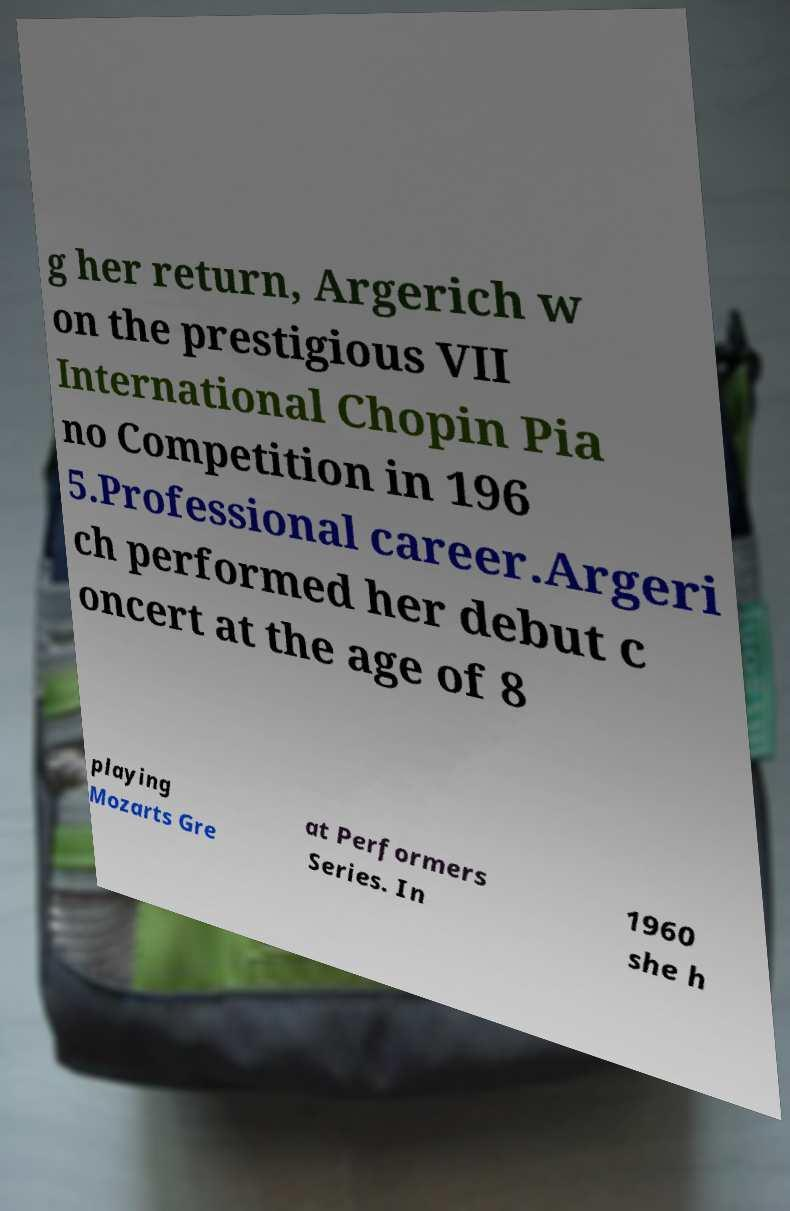Please read and relay the text visible in this image. What does it say? g her return, Argerich w on the prestigious VII International Chopin Pia no Competition in 196 5.Professional career.Argeri ch performed her debut c oncert at the age of 8 playing Mozarts Gre at Performers Series. In 1960 she h 